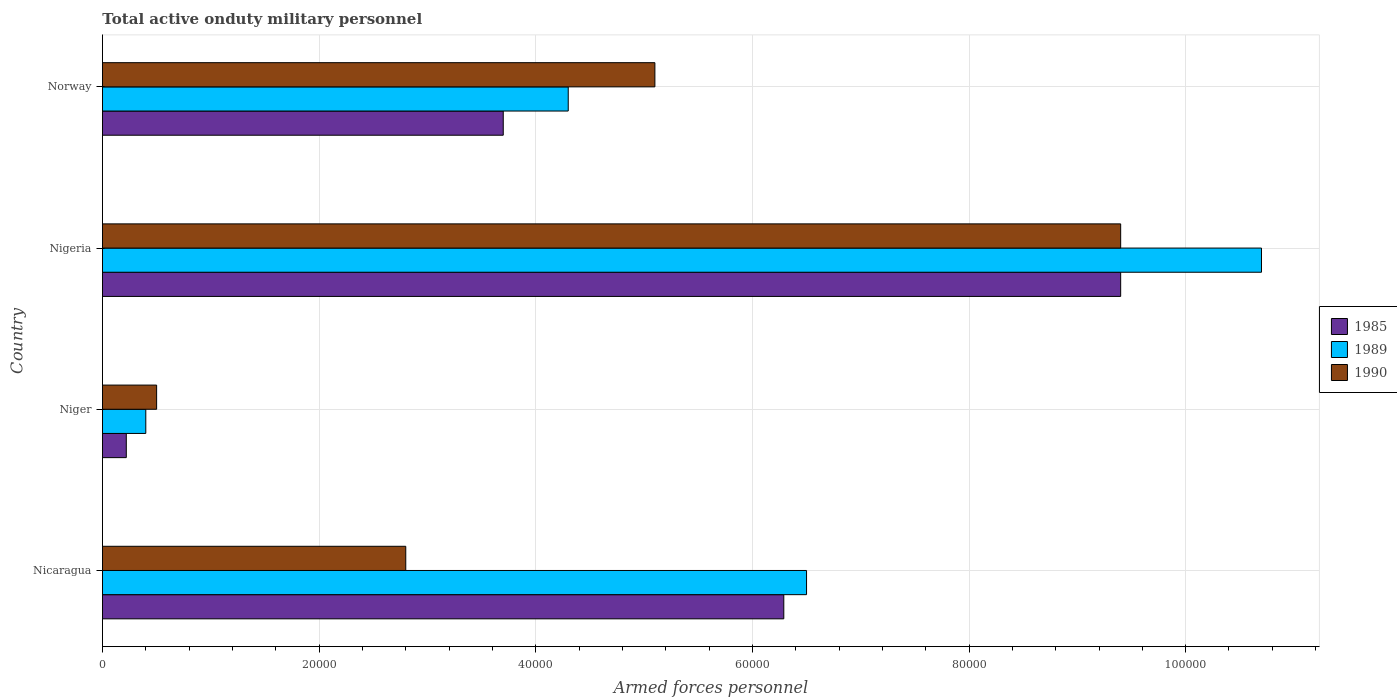How many different coloured bars are there?
Your answer should be compact. 3. How many groups of bars are there?
Provide a succinct answer. 4. Are the number of bars per tick equal to the number of legend labels?
Make the answer very short. Yes. Are the number of bars on each tick of the Y-axis equal?
Offer a terse response. Yes. How many bars are there on the 2nd tick from the top?
Your answer should be very brief. 3. What is the label of the 1st group of bars from the top?
Your answer should be very brief. Norway. What is the number of armed forces personnel in 1989 in Nigeria?
Ensure brevity in your answer.  1.07e+05. Across all countries, what is the maximum number of armed forces personnel in 1990?
Ensure brevity in your answer.  9.40e+04. Across all countries, what is the minimum number of armed forces personnel in 1990?
Keep it short and to the point. 5000. In which country was the number of armed forces personnel in 1989 maximum?
Your answer should be very brief. Nigeria. In which country was the number of armed forces personnel in 1985 minimum?
Offer a very short reply. Niger. What is the total number of armed forces personnel in 1985 in the graph?
Keep it short and to the point. 1.96e+05. What is the difference between the number of armed forces personnel in 1985 in Nicaragua and that in Norway?
Offer a terse response. 2.59e+04. What is the difference between the number of armed forces personnel in 1990 in Nicaragua and the number of armed forces personnel in 1989 in Nigeria?
Make the answer very short. -7.90e+04. What is the average number of armed forces personnel in 1989 per country?
Keep it short and to the point. 5.48e+04. What is the difference between the number of armed forces personnel in 1985 and number of armed forces personnel in 1990 in Norway?
Provide a short and direct response. -1.40e+04. In how many countries, is the number of armed forces personnel in 1989 greater than 88000 ?
Make the answer very short. 1. What is the ratio of the number of armed forces personnel in 1990 in Nicaragua to that in Norway?
Offer a very short reply. 0.55. What is the difference between the highest and the second highest number of armed forces personnel in 1985?
Your response must be concise. 3.11e+04. What is the difference between the highest and the lowest number of armed forces personnel in 1989?
Offer a very short reply. 1.03e+05. What does the 1st bar from the top in Norway represents?
Your answer should be compact. 1990. How many bars are there?
Offer a very short reply. 12. How many countries are there in the graph?
Provide a succinct answer. 4. Does the graph contain any zero values?
Give a very brief answer. No. Where does the legend appear in the graph?
Ensure brevity in your answer.  Center right. How are the legend labels stacked?
Ensure brevity in your answer.  Vertical. What is the title of the graph?
Provide a succinct answer. Total active onduty military personnel. What is the label or title of the X-axis?
Make the answer very short. Armed forces personnel. What is the label or title of the Y-axis?
Your answer should be compact. Country. What is the Armed forces personnel in 1985 in Nicaragua?
Your response must be concise. 6.29e+04. What is the Armed forces personnel of 1989 in Nicaragua?
Make the answer very short. 6.50e+04. What is the Armed forces personnel of 1990 in Nicaragua?
Give a very brief answer. 2.80e+04. What is the Armed forces personnel of 1985 in Niger?
Provide a succinct answer. 2200. What is the Armed forces personnel in 1989 in Niger?
Make the answer very short. 4000. What is the Armed forces personnel in 1985 in Nigeria?
Make the answer very short. 9.40e+04. What is the Armed forces personnel of 1989 in Nigeria?
Ensure brevity in your answer.  1.07e+05. What is the Armed forces personnel in 1990 in Nigeria?
Ensure brevity in your answer.  9.40e+04. What is the Armed forces personnel of 1985 in Norway?
Offer a terse response. 3.70e+04. What is the Armed forces personnel of 1989 in Norway?
Provide a succinct answer. 4.30e+04. What is the Armed forces personnel of 1990 in Norway?
Your answer should be very brief. 5.10e+04. Across all countries, what is the maximum Armed forces personnel in 1985?
Offer a terse response. 9.40e+04. Across all countries, what is the maximum Armed forces personnel in 1989?
Give a very brief answer. 1.07e+05. Across all countries, what is the maximum Armed forces personnel of 1990?
Keep it short and to the point. 9.40e+04. Across all countries, what is the minimum Armed forces personnel of 1985?
Your response must be concise. 2200. Across all countries, what is the minimum Armed forces personnel in 1989?
Ensure brevity in your answer.  4000. What is the total Armed forces personnel in 1985 in the graph?
Provide a short and direct response. 1.96e+05. What is the total Armed forces personnel of 1989 in the graph?
Offer a very short reply. 2.19e+05. What is the total Armed forces personnel in 1990 in the graph?
Make the answer very short. 1.78e+05. What is the difference between the Armed forces personnel in 1985 in Nicaragua and that in Niger?
Your answer should be compact. 6.07e+04. What is the difference between the Armed forces personnel of 1989 in Nicaragua and that in Niger?
Provide a short and direct response. 6.10e+04. What is the difference between the Armed forces personnel in 1990 in Nicaragua and that in Niger?
Your response must be concise. 2.30e+04. What is the difference between the Armed forces personnel of 1985 in Nicaragua and that in Nigeria?
Provide a succinct answer. -3.11e+04. What is the difference between the Armed forces personnel of 1989 in Nicaragua and that in Nigeria?
Offer a terse response. -4.20e+04. What is the difference between the Armed forces personnel of 1990 in Nicaragua and that in Nigeria?
Make the answer very short. -6.60e+04. What is the difference between the Armed forces personnel of 1985 in Nicaragua and that in Norway?
Your answer should be very brief. 2.59e+04. What is the difference between the Armed forces personnel in 1989 in Nicaragua and that in Norway?
Make the answer very short. 2.20e+04. What is the difference between the Armed forces personnel of 1990 in Nicaragua and that in Norway?
Your response must be concise. -2.30e+04. What is the difference between the Armed forces personnel of 1985 in Niger and that in Nigeria?
Provide a short and direct response. -9.18e+04. What is the difference between the Armed forces personnel of 1989 in Niger and that in Nigeria?
Your answer should be compact. -1.03e+05. What is the difference between the Armed forces personnel in 1990 in Niger and that in Nigeria?
Offer a very short reply. -8.90e+04. What is the difference between the Armed forces personnel of 1985 in Niger and that in Norway?
Provide a succinct answer. -3.48e+04. What is the difference between the Armed forces personnel of 1989 in Niger and that in Norway?
Keep it short and to the point. -3.90e+04. What is the difference between the Armed forces personnel in 1990 in Niger and that in Norway?
Your response must be concise. -4.60e+04. What is the difference between the Armed forces personnel in 1985 in Nigeria and that in Norway?
Offer a very short reply. 5.70e+04. What is the difference between the Armed forces personnel in 1989 in Nigeria and that in Norway?
Your answer should be compact. 6.40e+04. What is the difference between the Armed forces personnel of 1990 in Nigeria and that in Norway?
Provide a short and direct response. 4.30e+04. What is the difference between the Armed forces personnel in 1985 in Nicaragua and the Armed forces personnel in 1989 in Niger?
Give a very brief answer. 5.89e+04. What is the difference between the Armed forces personnel in 1985 in Nicaragua and the Armed forces personnel in 1990 in Niger?
Offer a very short reply. 5.79e+04. What is the difference between the Armed forces personnel of 1989 in Nicaragua and the Armed forces personnel of 1990 in Niger?
Your answer should be very brief. 6.00e+04. What is the difference between the Armed forces personnel in 1985 in Nicaragua and the Armed forces personnel in 1989 in Nigeria?
Provide a succinct answer. -4.41e+04. What is the difference between the Armed forces personnel in 1985 in Nicaragua and the Armed forces personnel in 1990 in Nigeria?
Offer a terse response. -3.11e+04. What is the difference between the Armed forces personnel in 1989 in Nicaragua and the Armed forces personnel in 1990 in Nigeria?
Keep it short and to the point. -2.90e+04. What is the difference between the Armed forces personnel in 1985 in Nicaragua and the Armed forces personnel in 1989 in Norway?
Keep it short and to the point. 1.99e+04. What is the difference between the Armed forces personnel of 1985 in Nicaragua and the Armed forces personnel of 1990 in Norway?
Provide a short and direct response. 1.19e+04. What is the difference between the Armed forces personnel of 1989 in Nicaragua and the Armed forces personnel of 1990 in Norway?
Provide a succinct answer. 1.40e+04. What is the difference between the Armed forces personnel in 1985 in Niger and the Armed forces personnel in 1989 in Nigeria?
Provide a succinct answer. -1.05e+05. What is the difference between the Armed forces personnel of 1985 in Niger and the Armed forces personnel of 1990 in Nigeria?
Offer a very short reply. -9.18e+04. What is the difference between the Armed forces personnel of 1985 in Niger and the Armed forces personnel of 1989 in Norway?
Keep it short and to the point. -4.08e+04. What is the difference between the Armed forces personnel in 1985 in Niger and the Armed forces personnel in 1990 in Norway?
Offer a terse response. -4.88e+04. What is the difference between the Armed forces personnel of 1989 in Niger and the Armed forces personnel of 1990 in Norway?
Your answer should be compact. -4.70e+04. What is the difference between the Armed forces personnel of 1985 in Nigeria and the Armed forces personnel of 1989 in Norway?
Offer a terse response. 5.10e+04. What is the difference between the Armed forces personnel of 1985 in Nigeria and the Armed forces personnel of 1990 in Norway?
Offer a terse response. 4.30e+04. What is the difference between the Armed forces personnel in 1989 in Nigeria and the Armed forces personnel in 1990 in Norway?
Keep it short and to the point. 5.60e+04. What is the average Armed forces personnel in 1985 per country?
Your answer should be compact. 4.90e+04. What is the average Armed forces personnel of 1989 per country?
Your response must be concise. 5.48e+04. What is the average Armed forces personnel in 1990 per country?
Your answer should be very brief. 4.45e+04. What is the difference between the Armed forces personnel in 1985 and Armed forces personnel in 1989 in Nicaragua?
Provide a short and direct response. -2100. What is the difference between the Armed forces personnel of 1985 and Armed forces personnel of 1990 in Nicaragua?
Offer a very short reply. 3.49e+04. What is the difference between the Armed forces personnel of 1989 and Armed forces personnel of 1990 in Nicaragua?
Offer a terse response. 3.70e+04. What is the difference between the Armed forces personnel of 1985 and Armed forces personnel of 1989 in Niger?
Your answer should be compact. -1800. What is the difference between the Armed forces personnel of 1985 and Armed forces personnel of 1990 in Niger?
Give a very brief answer. -2800. What is the difference between the Armed forces personnel of 1989 and Armed forces personnel of 1990 in Niger?
Provide a short and direct response. -1000. What is the difference between the Armed forces personnel of 1985 and Armed forces personnel of 1989 in Nigeria?
Provide a succinct answer. -1.30e+04. What is the difference between the Armed forces personnel in 1985 and Armed forces personnel in 1990 in Nigeria?
Your answer should be compact. 0. What is the difference between the Armed forces personnel in 1989 and Armed forces personnel in 1990 in Nigeria?
Ensure brevity in your answer.  1.30e+04. What is the difference between the Armed forces personnel of 1985 and Armed forces personnel of 1989 in Norway?
Your answer should be compact. -6000. What is the difference between the Armed forces personnel in 1985 and Armed forces personnel in 1990 in Norway?
Provide a short and direct response. -1.40e+04. What is the difference between the Armed forces personnel of 1989 and Armed forces personnel of 1990 in Norway?
Offer a very short reply. -8000. What is the ratio of the Armed forces personnel of 1985 in Nicaragua to that in Niger?
Your answer should be very brief. 28.59. What is the ratio of the Armed forces personnel in 1989 in Nicaragua to that in Niger?
Keep it short and to the point. 16.25. What is the ratio of the Armed forces personnel in 1985 in Nicaragua to that in Nigeria?
Give a very brief answer. 0.67. What is the ratio of the Armed forces personnel in 1989 in Nicaragua to that in Nigeria?
Offer a very short reply. 0.61. What is the ratio of the Armed forces personnel of 1990 in Nicaragua to that in Nigeria?
Offer a very short reply. 0.3. What is the ratio of the Armed forces personnel of 1985 in Nicaragua to that in Norway?
Your answer should be compact. 1.7. What is the ratio of the Armed forces personnel in 1989 in Nicaragua to that in Norway?
Provide a short and direct response. 1.51. What is the ratio of the Armed forces personnel of 1990 in Nicaragua to that in Norway?
Offer a terse response. 0.55. What is the ratio of the Armed forces personnel in 1985 in Niger to that in Nigeria?
Ensure brevity in your answer.  0.02. What is the ratio of the Armed forces personnel in 1989 in Niger to that in Nigeria?
Your answer should be very brief. 0.04. What is the ratio of the Armed forces personnel of 1990 in Niger to that in Nigeria?
Ensure brevity in your answer.  0.05. What is the ratio of the Armed forces personnel of 1985 in Niger to that in Norway?
Offer a very short reply. 0.06. What is the ratio of the Armed forces personnel of 1989 in Niger to that in Norway?
Give a very brief answer. 0.09. What is the ratio of the Armed forces personnel of 1990 in Niger to that in Norway?
Give a very brief answer. 0.1. What is the ratio of the Armed forces personnel in 1985 in Nigeria to that in Norway?
Give a very brief answer. 2.54. What is the ratio of the Armed forces personnel of 1989 in Nigeria to that in Norway?
Provide a short and direct response. 2.49. What is the ratio of the Armed forces personnel of 1990 in Nigeria to that in Norway?
Give a very brief answer. 1.84. What is the difference between the highest and the second highest Armed forces personnel in 1985?
Your answer should be compact. 3.11e+04. What is the difference between the highest and the second highest Armed forces personnel of 1989?
Your answer should be very brief. 4.20e+04. What is the difference between the highest and the second highest Armed forces personnel in 1990?
Provide a succinct answer. 4.30e+04. What is the difference between the highest and the lowest Armed forces personnel of 1985?
Your response must be concise. 9.18e+04. What is the difference between the highest and the lowest Armed forces personnel of 1989?
Provide a succinct answer. 1.03e+05. What is the difference between the highest and the lowest Armed forces personnel of 1990?
Make the answer very short. 8.90e+04. 